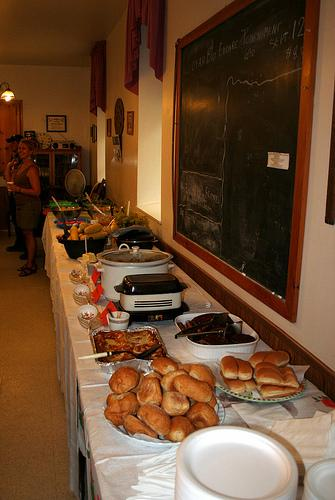Enumerate the key features of the image and their significance, if any. 5. Red curtains - adds to the warm ambiance of the room Summarize the main elements present in the image and their context. A woman with a cup is near a table filled with rolls, plates, and other food, implying a friendly social event. State the most prominent elements in the image and what they represent. A woman holding a cup represents a social gathering, while the table with food and plates suggests a buffet-style meal. Provide a short narrative describing the photograph. In a cozy room during a gathering, a blonde woman stands next to a table filled with delicious food, such as rolls in a bowl, and a stack of white plates for guests to use. Highlight the main objects and ambiance of the image. The image showcases a woman next to a food-filled table, with a warm and inviting atmosphere. Briefly describe the setting shown in the image, including the primary objects and any notable surroundings. The image displays a room with a woman holding a cup, and a table filled with food items and plates, set against the backdrop of a framed black-board on a wall and red window curtains. Mention the primary object or person in the image and their action. A woman with blonde hair is holding a cup near the table filled with food. Identify the main items on the table in the image. The table contains rolls of bread, a stack of white plates, hot roles on plates, and a white crock pot with a lid. Briefly describe the scene in the image. The image shows a woman close to a table with various food items and a framed blackboard on the wall. 